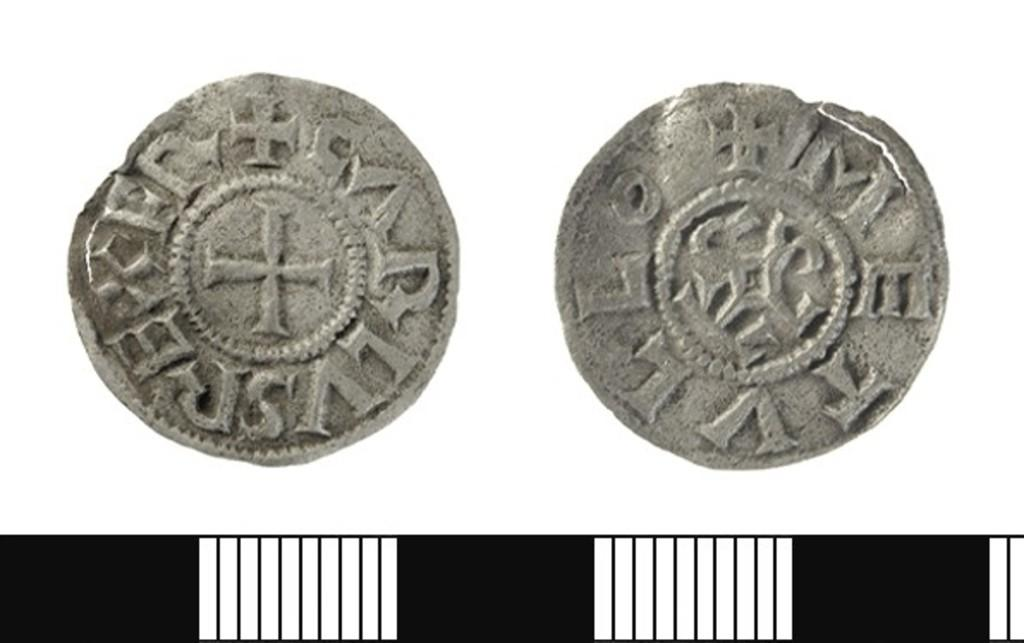<image>
Write a terse but informative summary of the picture. Two very old coins one with the symbols, M,E,T,V,L,L on it. 